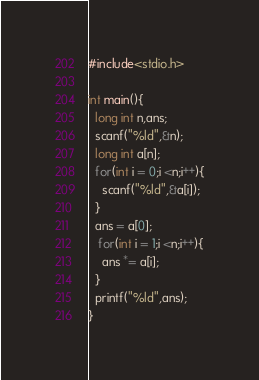Convert code to text. <code><loc_0><loc_0><loc_500><loc_500><_C_>#include<stdio.h>

int main(){
  long int n,ans;
  scanf("%ld",&n);
  long int a[n];  
  for(int i = 0;i <n;i++){
    scanf("%ld",&a[i]);
  }
  ans = a[0];
   for(int i = 1;i <n;i++){
    ans *= a[i];
  }
  printf("%ld",ans);
}
</code> 